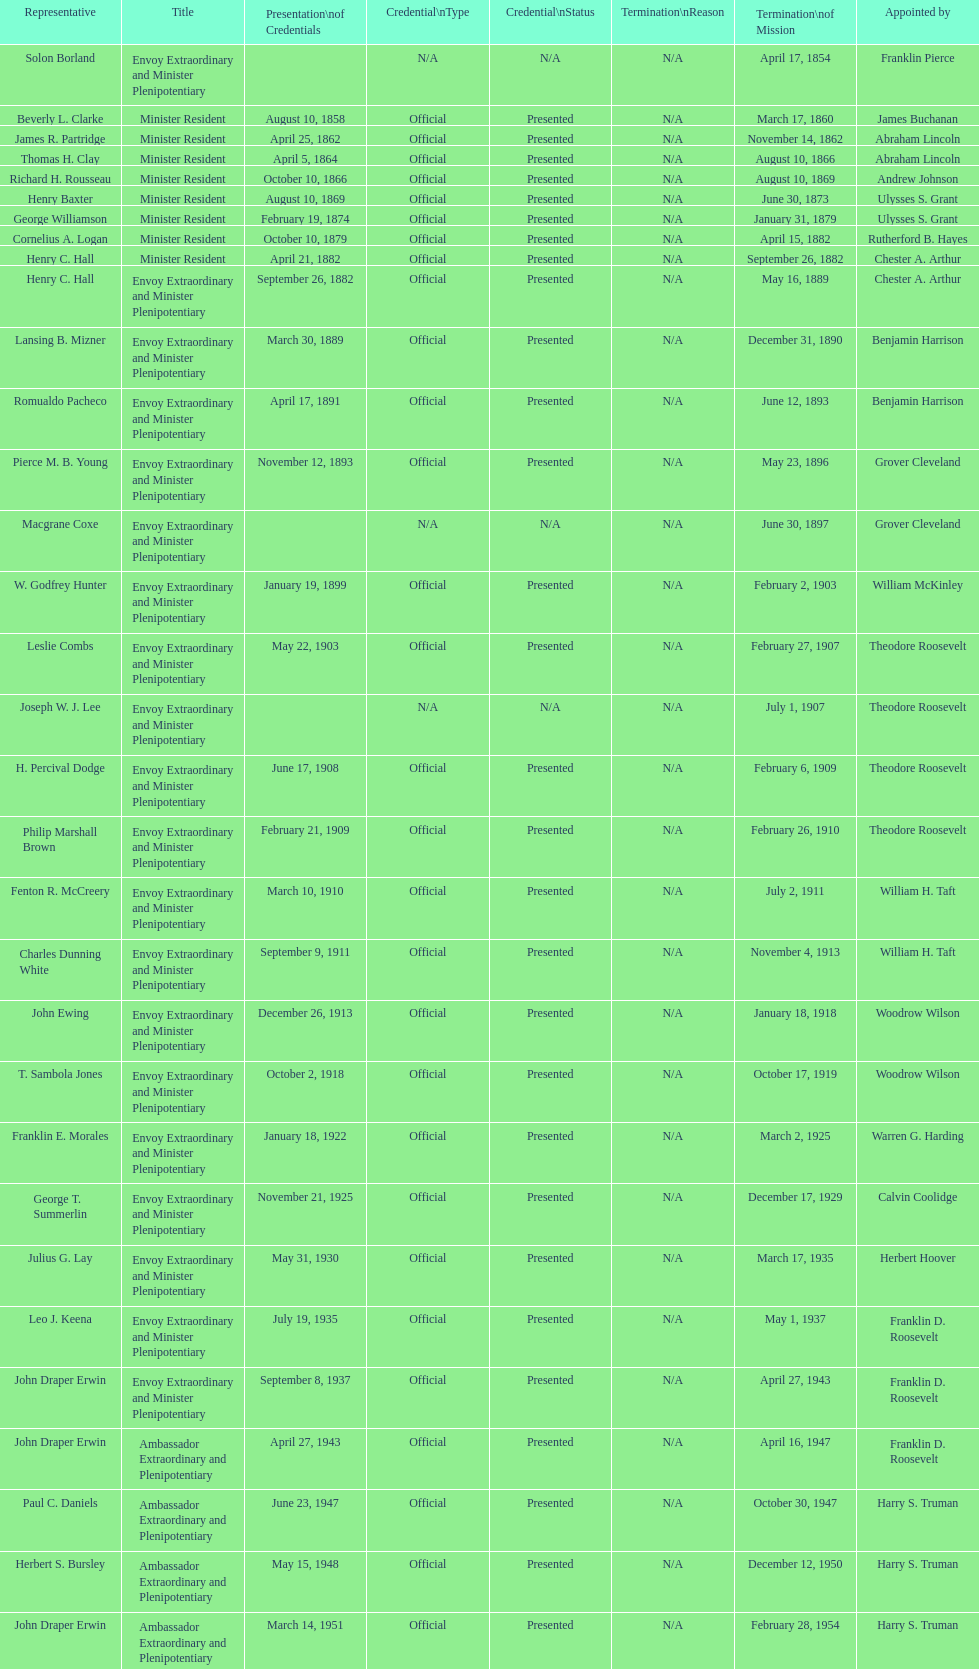Who is the only ambassadors to honduras appointed by barack obama? Lisa Kubiske. 